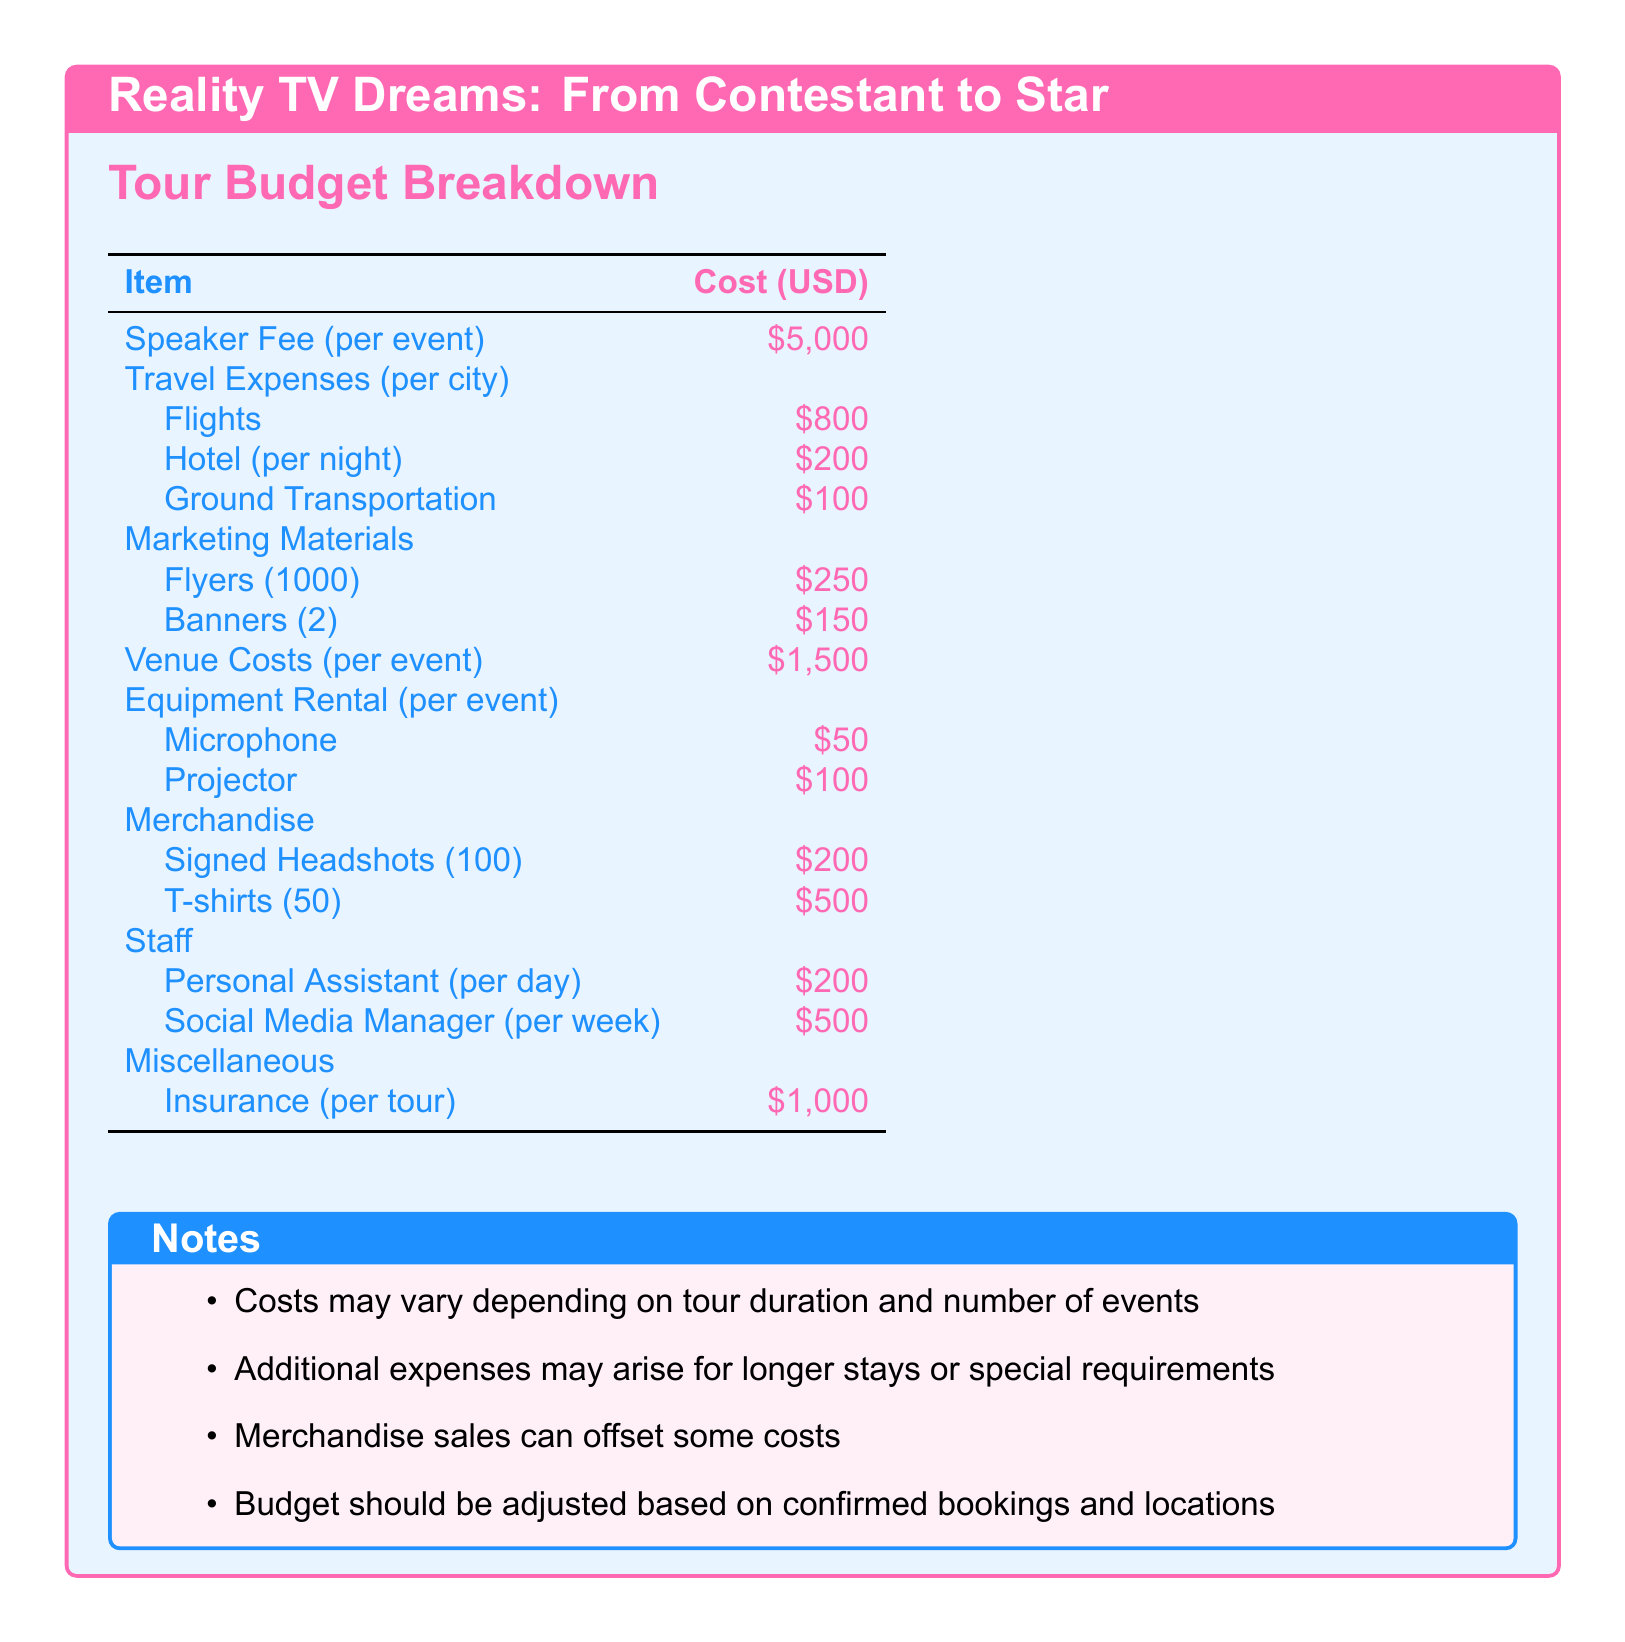what is the speaker fee per event? The speaker fee is listed as $5,000, which is the cost for each event.
Answer: $5,000 how much are the flights per city? The flights per city are specified as $800 in the travel expenses section.
Answer: $800 what is the cost for a microphone rental? The cost for a microphone rental is provided as $50 under equipment rental for each event.
Answer: $50 how much does it cost to produce 1000 flyers? The budget states that producing 1000 flyers costs $250 under marketing materials.
Answer: $250 what is the expense for insurance per tour? The document specifies that the insurance expense is $1,000 for the entire tour.
Answer: $1,000 how many T-shirts are included in the merchandise? The merchandise section includes 50 T-shirts.
Answer: 50 what is the total cost for venue costs for one event? The total cost for venue costs for one event is $1,500 as per the budget breakdown.
Answer: $1,500 how many headshots are planned for signing and sale? The plan includes 100 signed headshots for merchandise.
Answer: 100 what is the total cost for travel expenses (flights, hotel, and ground transportation) for one city? The total cost for travel expenses is calculated as $800 (flights) + $200 (hotel) + $100 (ground transportation) = $1100.
Answer: $1,100 